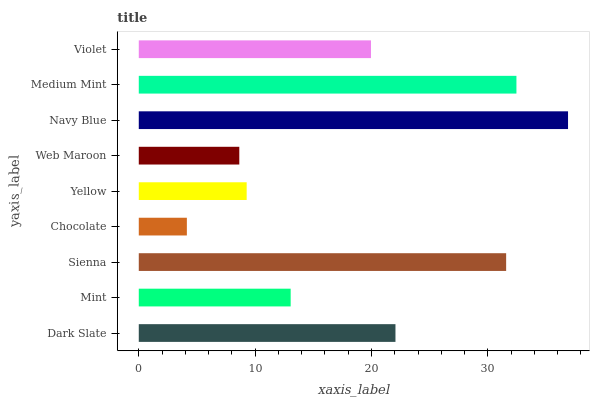Is Chocolate the minimum?
Answer yes or no. Yes. Is Navy Blue the maximum?
Answer yes or no. Yes. Is Mint the minimum?
Answer yes or no. No. Is Mint the maximum?
Answer yes or no. No. Is Dark Slate greater than Mint?
Answer yes or no. Yes. Is Mint less than Dark Slate?
Answer yes or no. Yes. Is Mint greater than Dark Slate?
Answer yes or no. No. Is Dark Slate less than Mint?
Answer yes or no. No. Is Violet the high median?
Answer yes or no. Yes. Is Violet the low median?
Answer yes or no. Yes. Is Sienna the high median?
Answer yes or no. No. Is Web Maroon the low median?
Answer yes or no. No. 